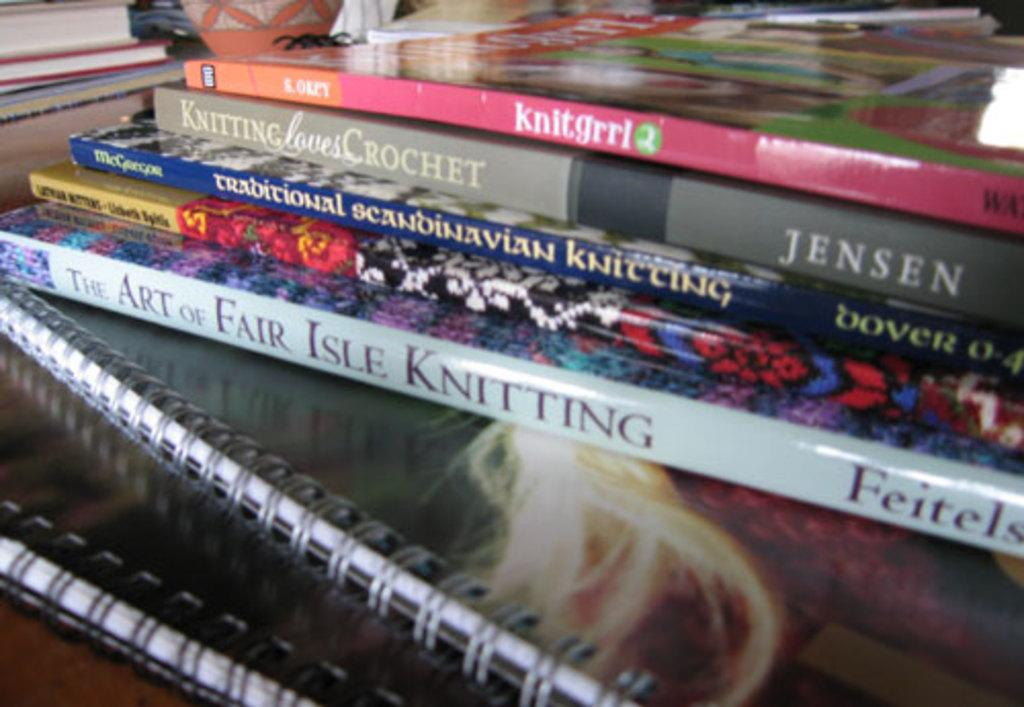<image>
Present a compact description of the photo's key features. Knitting Loves Crochet, Knitgrrl and Traditional Scandinavian Knitting are some of the titles visible in a jumble of craft books. 